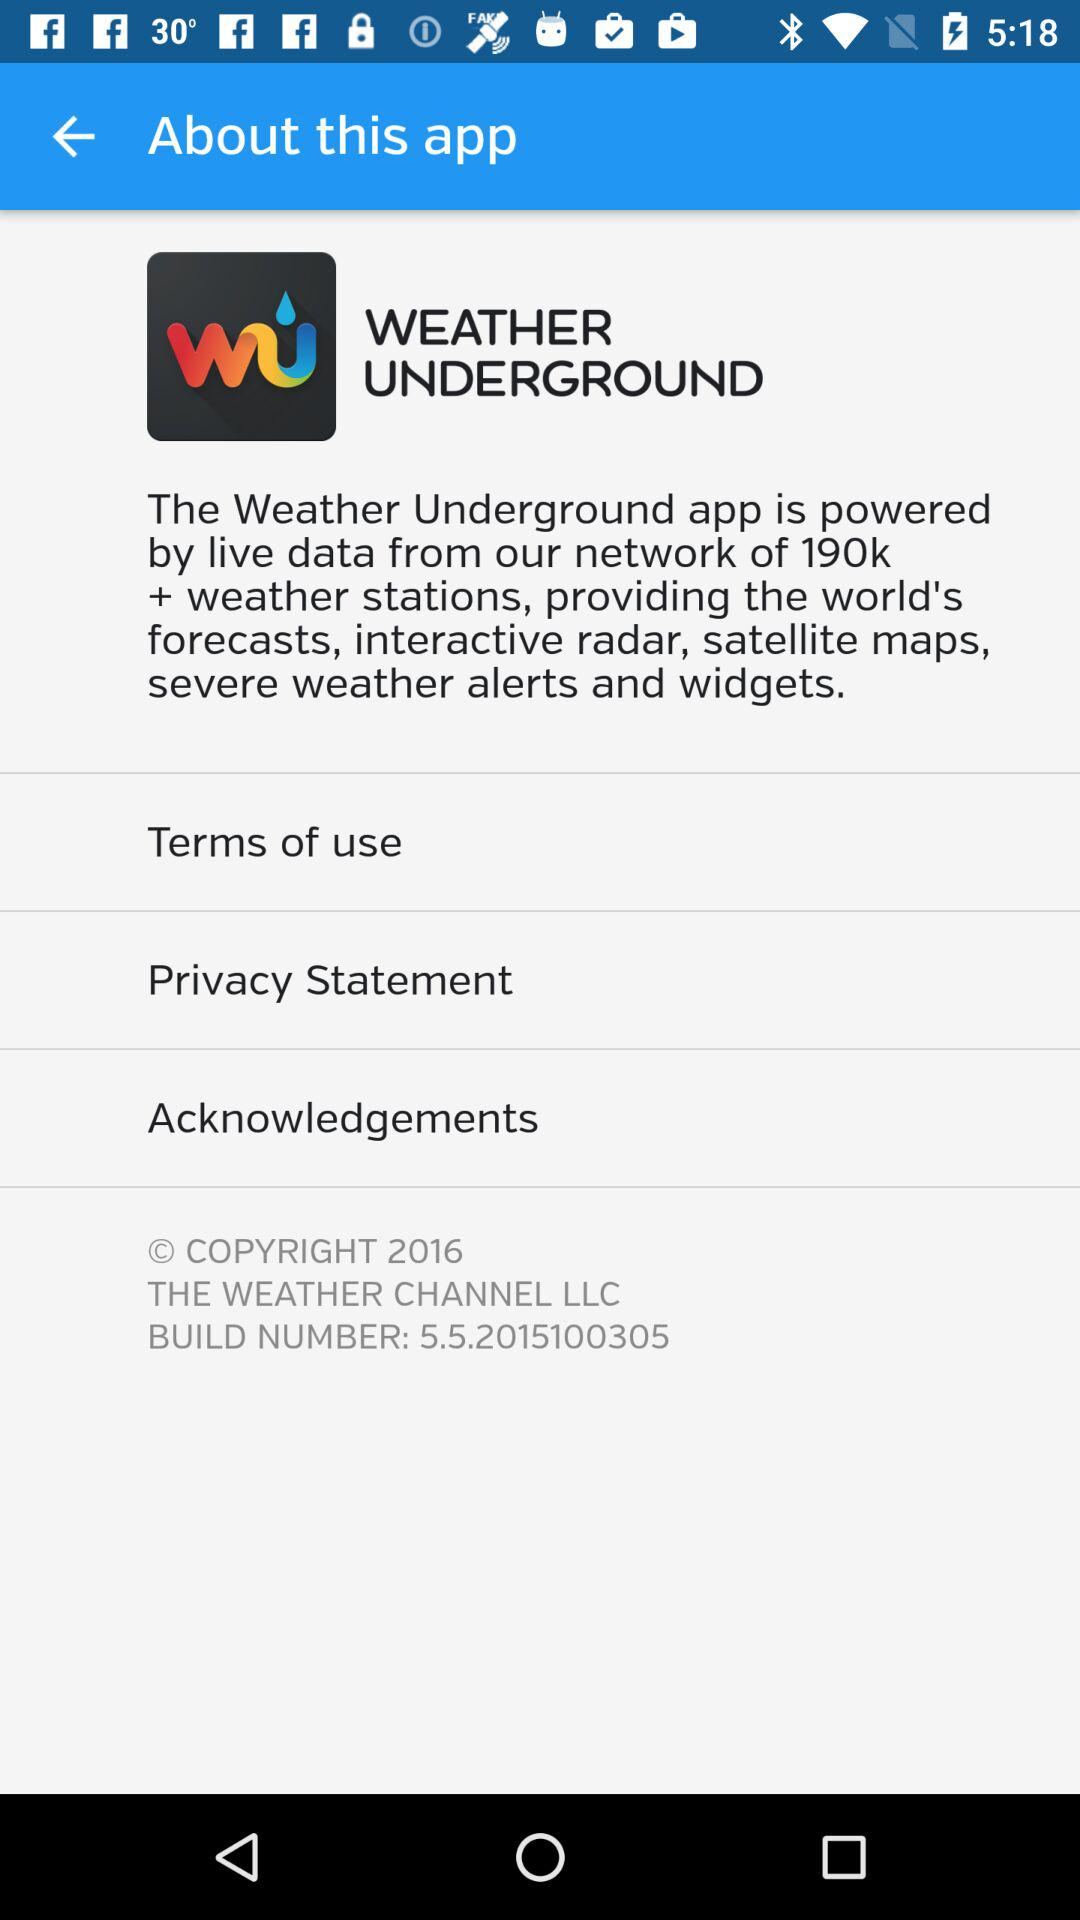What is the name of the app? The name of the app is "WEATHER UNDERGROUND". 